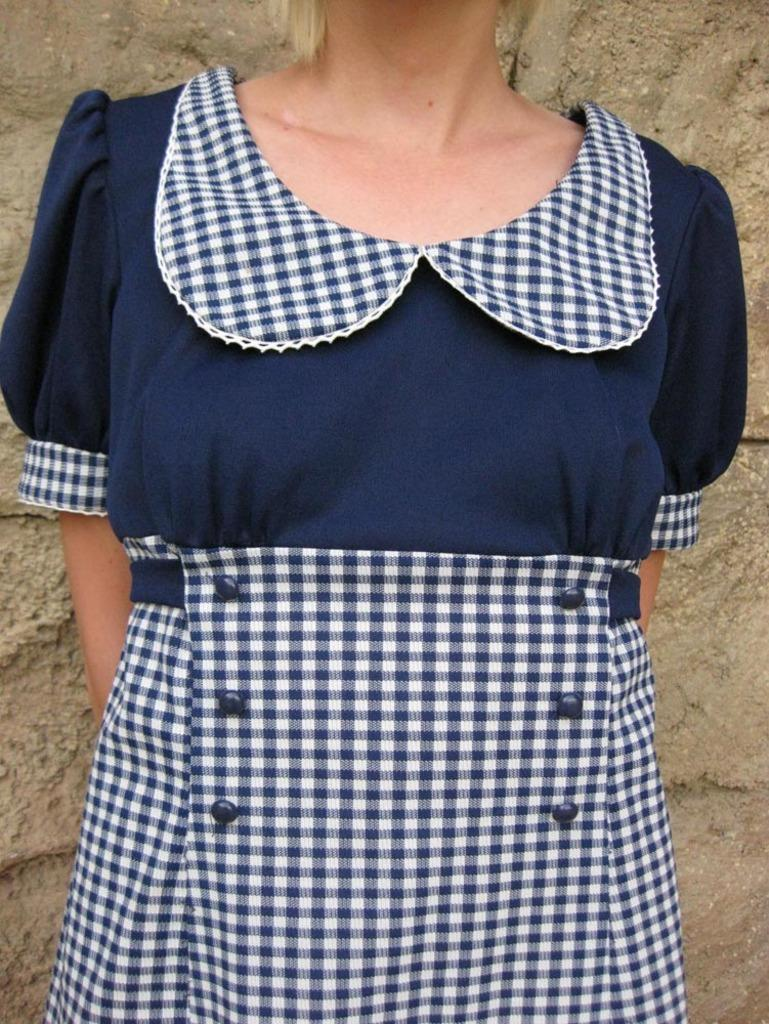Who is the main subject in the picture? There is a girl in the picture. What is the girl wearing? The girl is wearing a blue and white color checks dress. Where is the girl positioned in the image? The girl is standing in the front. What can be seen in the background of the image? There is a brown color wall in the background. What type of blade is the girl holding in the image? There is no blade present in the image; the girl is not holding any object. 